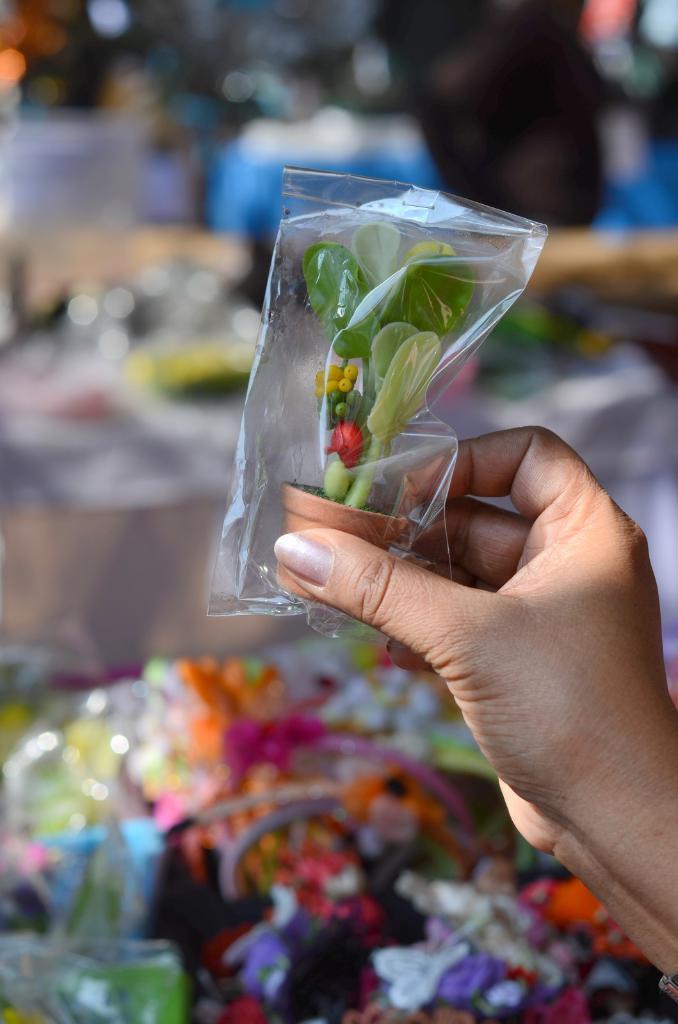In one or two sentences, can you explain what this image depicts? In this image we can see hand of a person with a packet. Inside the packet we can see a toy pot with plant. In the background there are few objects and it is blurry. 